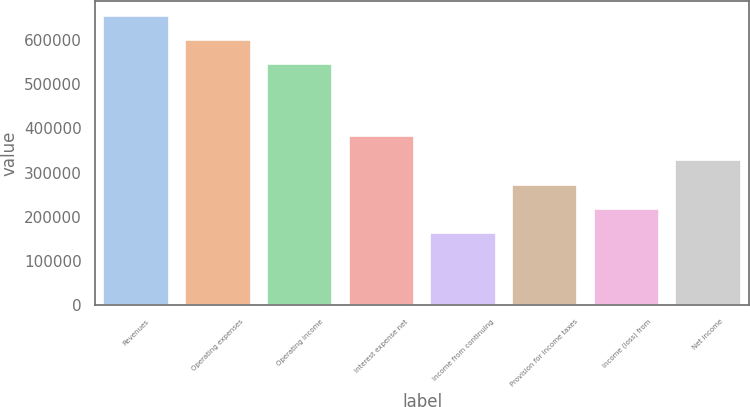Convert chart to OTSL. <chart><loc_0><loc_0><loc_500><loc_500><bar_chart><fcel>Revenues<fcel>Operating expenses<fcel>Operating income<fcel>Interest expense net<fcel>Income from continuing<fcel>Provision for income taxes<fcel>Income (loss) from<fcel>Net income<nl><fcel>655104<fcel>600512<fcel>545920<fcel>382144<fcel>163777<fcel>272960<fcel>218368<fcel>327552<nl></chart> 